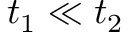<formula> <loc_0><loc_0><loc_500><loc_500>t _ { 1 } \ll t _ { 2 }</formula> 